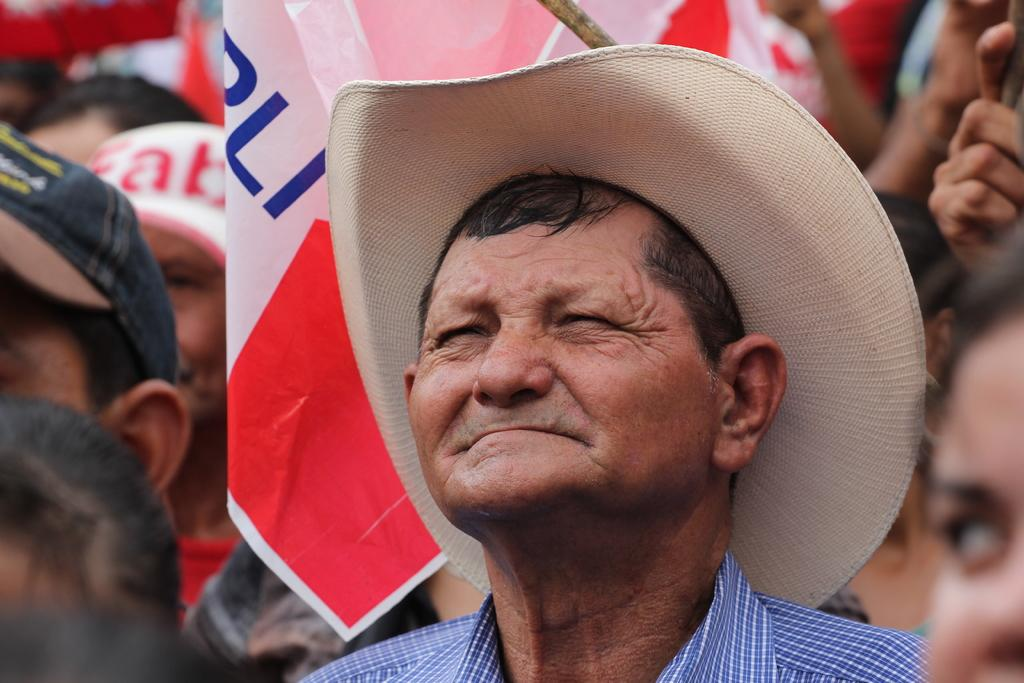How many individuals are present in the image? There are many people in the image. What are the people wearing in the image? The people are wearing clothes. What can be seen in the image besides the people? There is a flag, a hat, and a cap in the image. What type of playground equipment can be seen in the image? There is no playground equipment present in the image. Is there any indication of a competition taking place in the image? There is no indication of a competition in the image. 